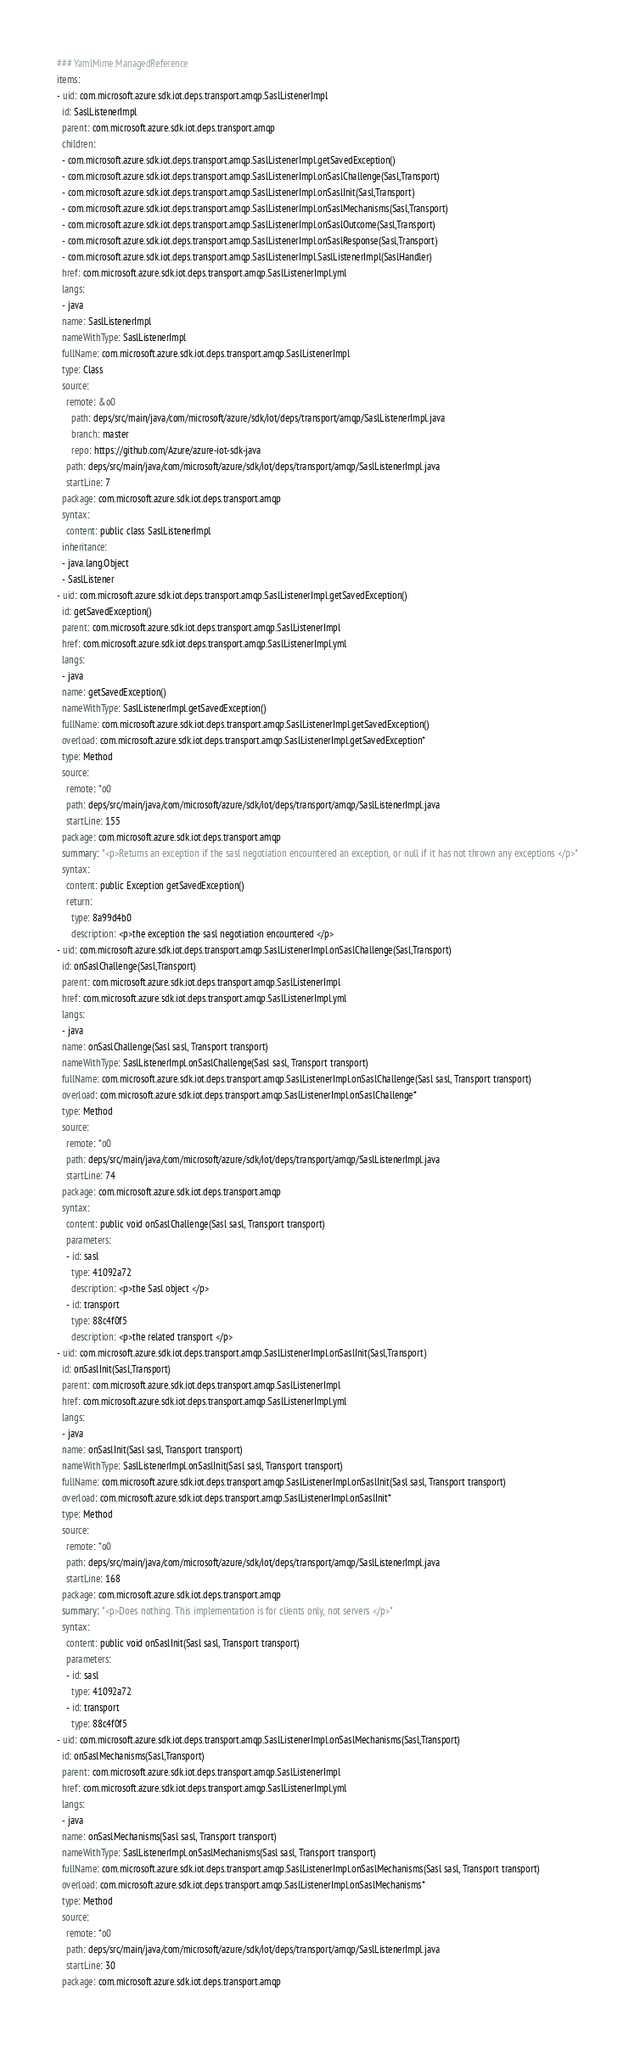Convert code to text. <code><loc_0><loc_0><loc_500><loc_500><_YAML_>### YamlMime:ManagedReference
items:
- uid: com.microsoft.azure.sdk.iot.deps.transport.amqp.SaslListenerImpl
  id: SaslListenerImpl
  parent: com.microsoft.azure.sdk.iot.deps.transport.amqp
  children:
  - com.microsoft.azure.sdk.iot.deps.transport.amqp.SaslListenerImpl.getSavedException()
  - com.microsoft.azure.sdk.iot.deps.transport.amqp.SaslListenerImpl.onSaslChallenge(Sasl,Transport)
  - com.microsoft.azure.sdk.iot.deps.transport.amqp.SaslListenerImpl.onSaslInit(Sasl,Transport)
  - com.microsoft.azure.sdk.iot.deps.transport.amqp.SaslListenerImpl.onSaslMechanisms(Sasl,Transport)
  - com.microsoft.azure.sdk.iot.deps.transport.amqp.SaslListenerImpl.onSaslOutcome(Sasl,Transport)
  - com.microsoft.azure.sdk.iot.deps.transport.amqp.SaslListenerImpl.onSaslResponse(Sasl,Transport)
  - com.microsoft.azure.sdk.iot.deps.transport.amqp.SaslListenerImpl.SaslListenerImpl(SaslHandler)
  href: com.microsoft.azure.sdk.iot.deps.transport.amqp.SaslListenerImpl.yml
  langs:
  - java
  name: SaslListenerImpl
  nameWithType: SaslListenerImpl
  fullName: com.microsoft.azure.sdk.iot.deps.transport.amqp.SaslListenerImpl
  type: Class
  source:
    remote: &o0
      path: deps/src/main/java/com/microsoft/azure/sdk/iot/deps/transport/amqp/SaslListenerImpl.java
      branch: master
      repo: https://github.com/Azure/azure-iot-sdk-java
    path: deps/src/main/java/com/microsoft/azure/sdk/iot/deps/transport/amqp/SaslListenerImpl.java
    startLine: 7
  package: com.microsoft.azure.sdk.iot.deps.transport.amqp
  syntax:
    content: public class SaslListenerImpl
  inheritance:
  - java.lang.Object
  - SaslListener
- uid: com.microsoft.azure.sdk.iot.deps.transport.amqp.SaslListenerImpl.getSavedException()
  id: getSavedException()
  parent: com.microsoft.azure.sdk.iot.deps.transport.amqp.SaslListenerImpl
  href: com.microsoft.azure.sdk.iot.deps.transport.amqp.SaslListenerImpl.yml
  langs:
  - java
  name: getSavedException()
  nameWithType: SaslListenerImpl.getSavedException()
  fullName: com.microsoft.azure.sdk.iot.deps.transport.amqp.SaslListenerImpl.getSavedException()
  overload: com.microsoft.azure.sdk.iot.deps.transport.amqp.SaslListenerImpl.getSavedException*
  type: Method
  source:
    remote: *o0
    path: deps/src/main/java/com/microsoft/azure/sdk/iot/deps/transport/amqp/SaslListenerImpl.java
    startLine: 155
  package: com.microsoft.azure.sdk.iot.deps.transport.amqp
  summary: "<p>Returns an exception if the sasl negotiation encountered an exception, or null if it has not thrown any exceptions </p>"
  syntax:
    content: public Exception getSavedException()
    return:
      type: 8a99d4b0
      description: <p>the exception the sasl negotiation encountered </p>
- uid: com.microsoft.azure.sdk.iot.deps.transport.amqp.SaslListenerImpl.onSaslChallenge(Sasl,Transport)
  id: onSaslChallenge(Sasl,Transport)
  parent: com.microsoft.azure.sdk.iot.deps.transport.amqp.SaslListenerImpl
  href: com.microsoft.azure.sdk.iot.deps.transport.amqp.SaslListenerImpl.yml
  langs:
  - java
  name: onSaslChallenge(Sasl sasl, Transport transport)
  nameWithType: SaslListenerImpl.onSaslChallenge(Sasl sasl, Transport transport)
  fullName: com.microsoft.azure.sdk.iot.deps.transport.amqp.SaslListenerImpl.onSaslChallenge(Sasl sasl, Transport transport)
  overload: com.microsoft.azure.sdk.iot.deps.transport.amqp.SaslListenerImpl.onSaslChallenge*
  type: Method
  source:
    remote: *o0
    path: deps/src/main/java/com/microsoft/azure/sdk/iot/deps/transport/amqp/SaslListenerImpl.java
    startLine: 74
  package: com.microsoft.azure.sdk.iot.deps.transport.amqp
  syntax:
    content: public void onSaslChallenge(Sasl sasl, Transport transport)
    parameters:
    - id: sasl
      type: 41092a72
      description: <p>the Sasl object </p>
    - id: transport
      type: 88c4f0f5
      description: <p>the related transport </p>
- uid: com.microsoft.azure.sdk.iot.deps.transport.amqp.SaslListenerImpl.onSaslInit(Sasl,Transport)
  id: onSaslInit(Sasl,Transport)
  parent: com.microsoft.azure.sdk.iot.deps.transport.amqp.SaslListenerImpl
  href: com.microsoft.azure.sdk.iot.deps.transport.amqp.SaslListenerImpl.yml
  langs:
  - java
  name: onSaslInit(Sasl sasl, Transport transport)
  nameWithType: SaslListenerImpl.onSaslInit(Sasl sasl, Transport transport)
  fullName: com.microsoft.azure.sdk.iot.deps.transport.amqp.SaslListenerImpl.onSaslInit(Sasl sasl, Transport transport)
  overload: com.microsoft.azure.sdk.iot.deps.transport.amqp.SaslListenerImpl.onSaslInit*
  type: Method
  source:
    remote: *o0
    path: deps/src/main/java/com/microsoft/azure/sdk/iot/deps/transport/amqp/SaslListenerImpl.java
    startLine: 168
  package: com.microsoft.azure.sdk.iot.deps.transport.amqp
  summary: "<p>Does nothing. This implementation is for clients only, not servers </p>"
  syntax:
    content: public void onSaslInit(Sasl sasl, Transport transport)
    parameters:
    - id: sasl
      type: 41092a72
    - id: transport
      type: 88c4f0f5
- uid: com.microsoft.azure.sdk.iot.deps.transport.amqp.SaslListenerImpl.onSaslMechanisms(Sasl,Transport)
  id: onSaslMechanisms(Sasl,Transport)
  parent: com.microsoft.azure.sdk.iot.deps.transport.amqp.SaslListenerImpl
  href: com.microsoft.azure.sdk.iot.deps.transport.amqp.SaslListenerImpl.yml
  langs:
  - java
  name: onSaslMechanisms(Sasl sasl, Transport transport)
  nameWithType: SaslListenerImpl.onSaslMechanisms(Sasl sasl, Transport transport)
  fullName: com.microsoft.azure.sdk.iot.deps.transport.amqp.SaslListenerImpl.onSaslMechanisms(Sasl sasl, Transport transport)
  overload: com.microsoft.azure.sdk.iot.deps.transport.amqp.SaslListenerImpl.onSaslMechanisms*
  type: Method
  source:
    remote: *o0
    path: deps/src/main/java/com/microsoft/azure/sdk/iot/deps/transport/amqp/SaslListenerImpl.java
    startLine: 30
  package: com.microsoft.azure.sdk.iot.deps.transport.amqp</code> 